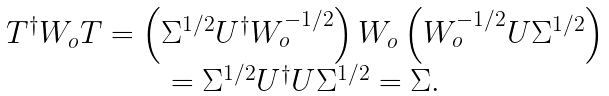<formula> <loc_0><loc_0><loc_500><loc_500>\begin{array} { c } T ^ { \dagger } W _ { o } T = \left ( \Sigma ^ { 1 / 2 } U ^ { \dagger } W _ { o } ^ { - 1 / 2 } \right ) W _ { o } \left ( W _ { o } ^ { - 1 / 2 } U \Sigma ^ { 1 / 2 } \right ) \\ = \Sigma ^ { 1 / 2 } U ^ { \dagger } U \Sigma ^ { 1 / 2 } = \Sigma . \end{array}</formula> 